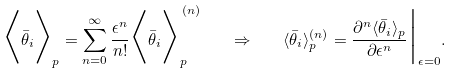<formula> <loc_0><loc_0><loc_500><loc_500>\Big \langle \bar { \theta } _ { i } \Big \rangle _ { p } = \sum _ { n = 0 } ^ { \infty } \frac { \epsilon ^ { n } } { n ! } \Big \langle \bar { \theta } _ { i } \Big \rangle _ { p } ^ { \, ( n ) } \quad \Rightarrow \quad \langle \bar { \theta } _ { i } \rangle _ { p } ^ { ( n ) } = \frac { \partial ^ { n } \langle \bar { \theta } _ { i } \rangle _ { p } } { \partial \epsilon ^ { n } } \Big | _ { \epsilon = 0 } .</formula> 